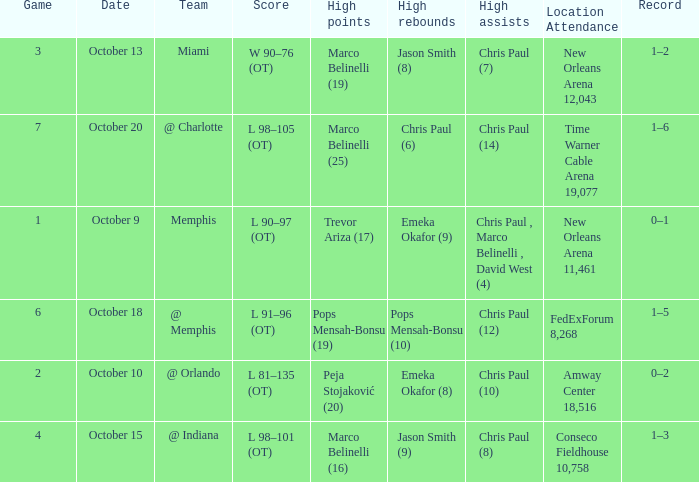What team did the Hornets play in game 4? @ Indiana. 